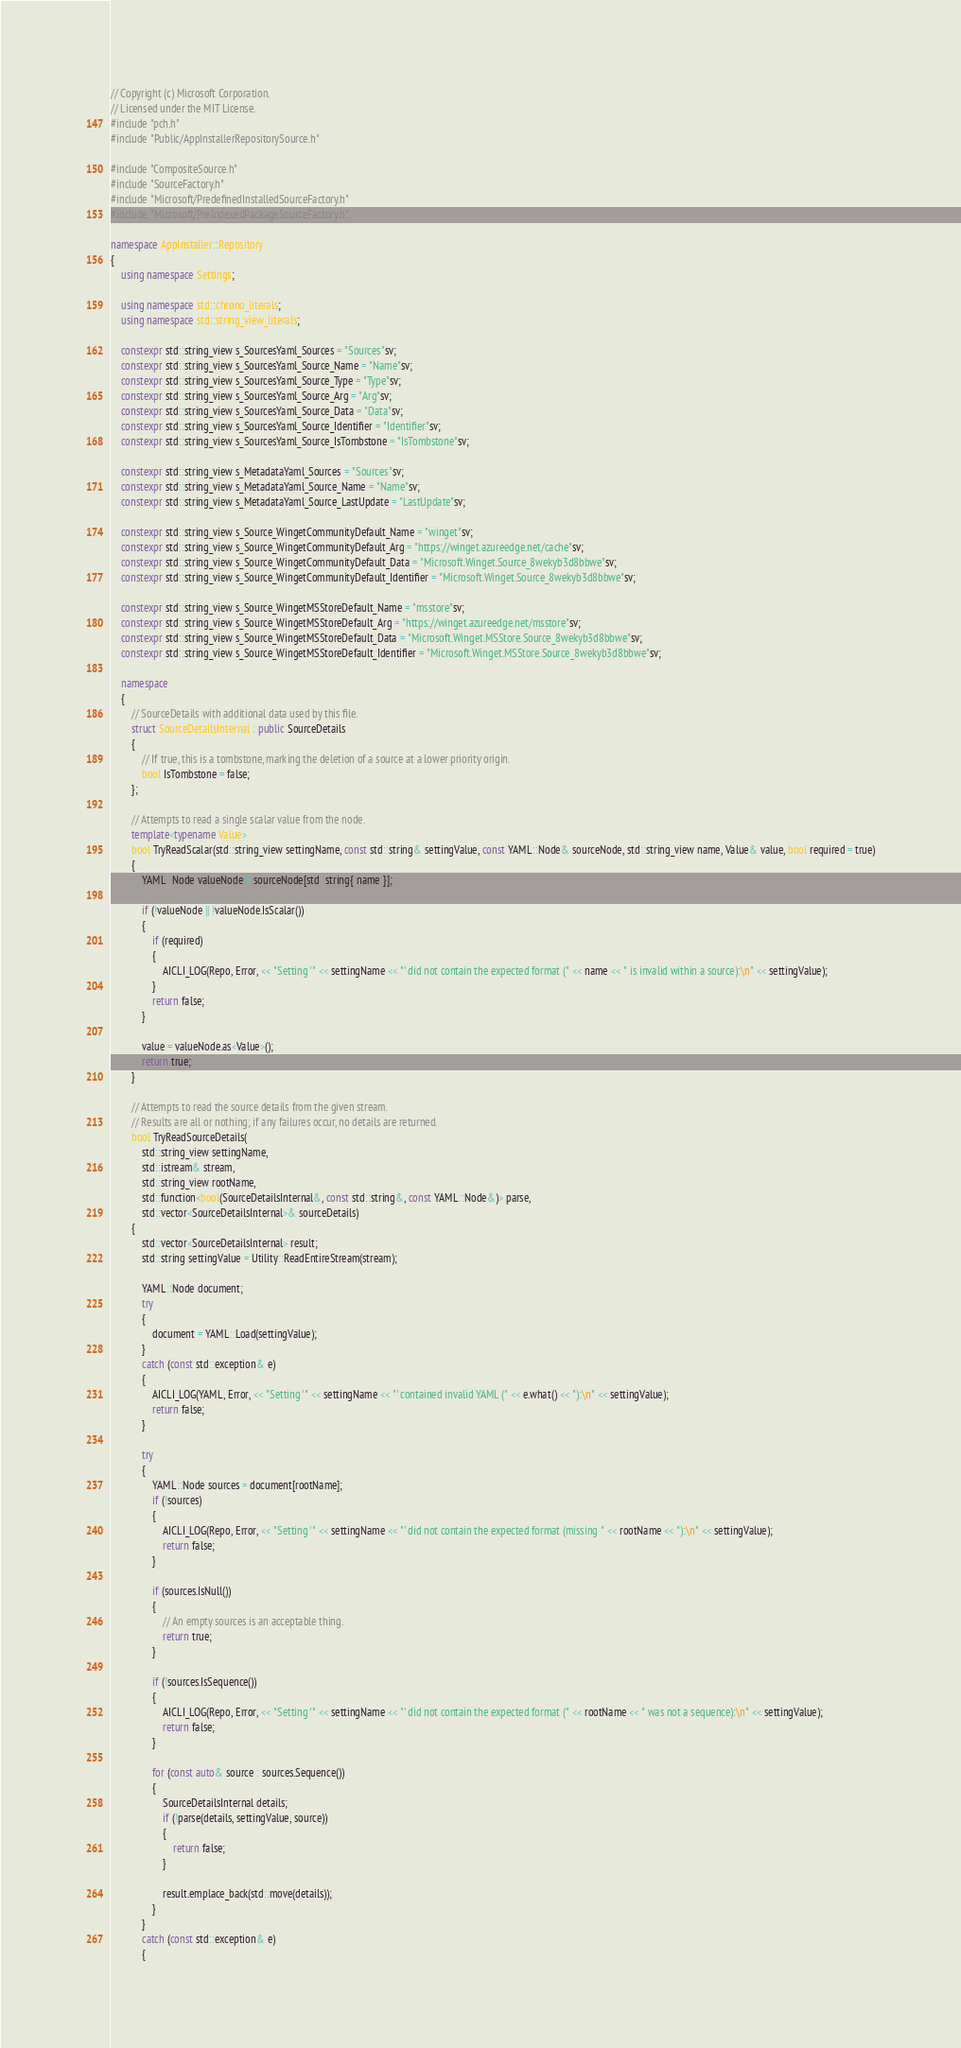Convert code to text. <code><loc_0><loc_0><loc_500><loc_500><_C++_>// Copyright (c) Microsoft Corporation.
// Licensed under the MIT License.
#include "pch.h"
#include "Public/AppInstallerRepositorySource.h"

#include "CompositeSource.h"
#include "SourceFactory.h"
#include "Microsoft/PredefinedInstalledSourceFactory.h"
#include "Microsoft/PreIndexedPackageSourceFactory.h"

namespace AppInstaller::Repository
{
    using namespace Settings;

    using namespace std::chrono_literals;
    using namespace std::string_view_literals;

    constexpr std::string_view s_SourcesYaml_Sources = "Sources"sv;
    constexpr std::string_view s_SourcesYaml_Source_Name = "Name"sv;
    constexpr std::string_view s_SourcesYaml_Source_Type = "Type"sv;
    constexpr std::string_view s_SourcesYaml_Source_Arg = "Arg"sv;
    constexpr std::string_view s_SourcesYaml_Source_Data = "Data"sv;
    constexpr std::string_view s_SourcesYaml_Source_Identifier = "Identifier"sv;
    constexpr std::string_view s_SourcesYaml_Source_IsTombstone = "IsTombstone"sv;

    constexpr std::string_view s_MetadataYaml_Sources = "Sources"sv;
    constexpr std::string_view s_MetadataYaml_Source_Name = "Name"sv;
    constexpr std::string_view s_MetadataYaml_Source_LastUpdate = "LastUpdate"sv;

    constexpr std::string_view s_Source_WingetCommunityDefault_Name = "winget"sv;
    constexpr std::string_view s_Source_WingetCommunityDefault_Arg = "https://winget.azureedge.net/cache"sv;
    constexpr std::string_view s_Source_WingetCommunityDefault_Data = "Microsoft.Winget.Source_8wekyb3d8bbwe"sv;
    constexpr std::string_view s_Source_WingetCommunityDefault_Identifier = "Microsoft.Winget.Source_8wekyb3d8bbwe"sv;

    constexpr std::string_view s_Source_WingetMSStoreDefault_Name = "msstore"sv;
    constexpr std::string_view s_Source_WingetMSStoreDefault_Arg = "https://winget.azureedge.net/msstore"sv;
    constexpr std::string_view s_Source_WingetMSStoreDefault_Data = "Microsoft.Winget.MSStore.Source_8wekyb3d8bbwe"sv;
    constexpr std::string_view s_Source_WingetMSStoreDefault_Identifier = "Microsoft.Winget.MSStore.Source_8wekyb3d8bbwe"sv;

    namespace
    {
        // SourceDetails with additional data used by this file.
        struct SourceDetailsInternal : public SourceDetails
        {
            // If true, this is a tombstone, marking the deletion of a source at a lower priority origin.
            bool IsTombstone = false;
        };

        // Attempts to read a single scalar value from the node.
        template<typename Value>
        bool TryReadScalar(std::string_view settingName, const std::string& settingValue, const YAML::Node& sourceNode, std::string_view name, Value& value, bool required = true)
        {
            YAML::Node valueNode = sourceNode[std::string{ name }];

            if (!valueNode || !valueNode.IsScalar())
            {
                if (required)
                {
                    AICLI_LOG(Repo, Error, << "Setting '" << settingName << "' did not contain the expected format (" << name << " is invalid within a source):\n" << settingValue);
                }
                return false;
            }

            value = valueNode.as<Value>();
            return true;
        }

        // Attempts to read the source details from the given stream.
        // Results are all or nothing; if any failures occur, no details are returned.
        bool TryReadSourceDetails(
            std::string_view settingName,
            std::istream& stream,
            std::string_view rootName,
            std::function<bool(SourceDetailsInternal&, const std::string&, const YAML::Node&)> parse,
            std::vector<SourceDetailsInternal>& sourceDetails)
        {
            std::vector<SourceDetailsInternal> result;
            std::string settingValue = Utility::ReadEntireStream(stream);

            YAML::Node document;
            try
            {
                document = YAML::Load(settingValue);
            }
            catch (const std::exception& e)
            {
                AICLI_LOG(YAML, Error, << "Setting '" << settingName << "' contained invalid YAML (" << e.what() << "):\n" << settingValue);
                return false;
            }

            try
            {
                YAML::Node sources = document[rootName];
                if (!sources)
                {
                    AICLI_LOG(Repo, Error, << "Setting '" << settingName << "' did not contain the expected format (missing " << rootName << "):\n" << settingValue);
                    return false;
                }

                if (sources.IsNull())
                {
                    // An empty sources is an acceptable thing.
                    return true;
                }

                if (!sources.IsSequence())
                {
                    AICLI_LOG(Repo, Error, << "Setting '" << settingName << "' did not contain the expected format (" << rootName << " was not a sequence):\n" << settingValue);
                    return false;
                }

                for (const auto& source : sources.Sequence())
                {
                    SourceDetailsInternal details;
                    if (!parse(details, settingValue, source))
                    {
                        return false;
                    }

                    result.emplace_back(std::move(details));
                }
            }
            catch (const std::exception& e)
            {</code> 